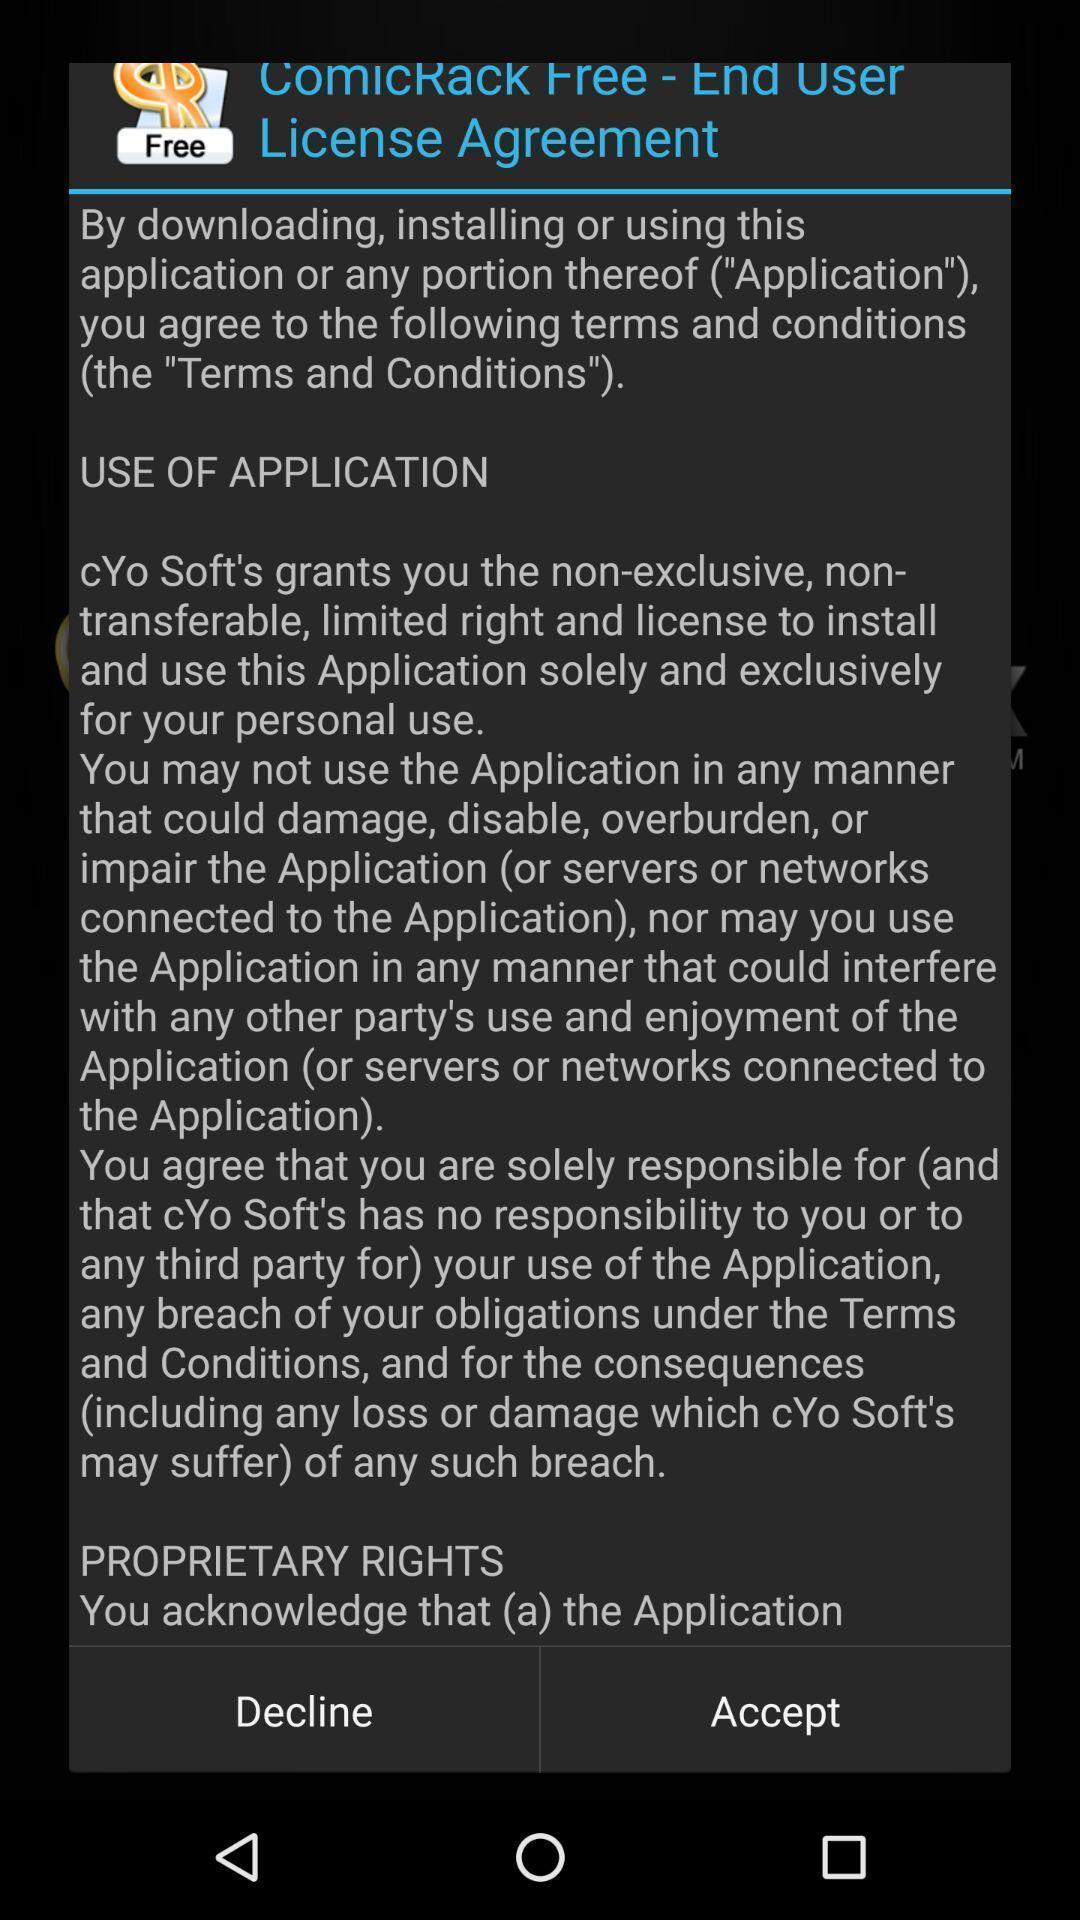Summarize the information in this screenshot. Screen displaying the license agreement to accept. 